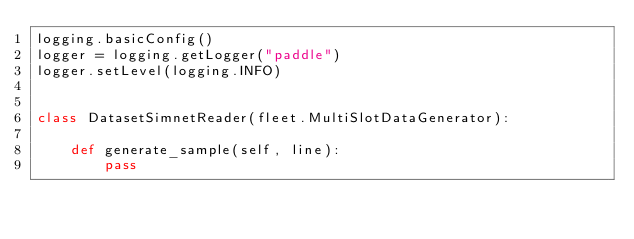<code> <loc_0><loc_0><loc_500><loc_500><_Python_>logging.basicConfig()
logger = logging.getLogger("paddle")
logger.setLevel(logging.INFO)


class DatasetSimnetReader(fleet.MultiSlotDataGenerator):

    def generate_sample(self, line):
        pass
</code> 